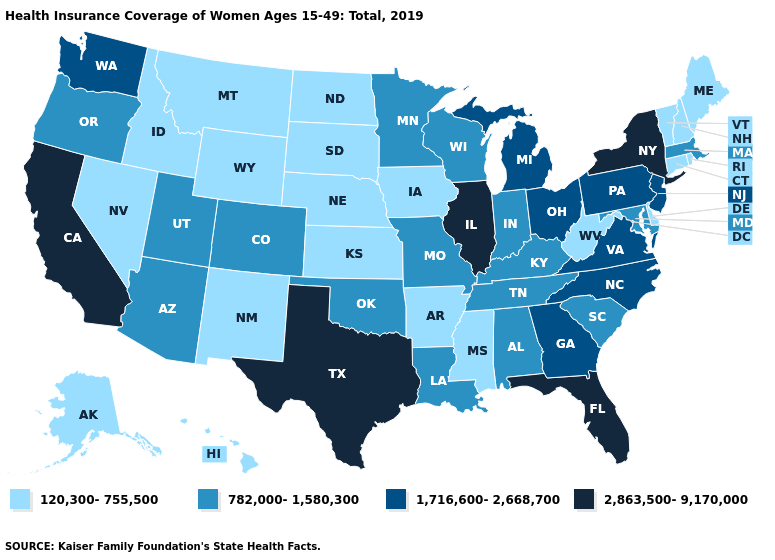Does Indiana have the same value as Pennsylvania?
Short answer required. No. What is the lowest value in the USA?
Be succinct. 120,300-755,500. How many symbols are there in the legend?
Write a very short answer. 4. What is the value of Utah?
Short answer required. 782,000-1,580,300. What is the value of Georgia?
Be succinct. 1,716,600-2,668,700. Name the states that have a value in the range 782,000-1,580,300?
Answer briefly. Alabama, Arizona, Colorado, Indiana, Kentucky, Louisiana, Maryland, Massachusetts, Minnesota, Missouri, Oklahoma, Oregon, South Carolina, Tennessee, Utah, Wisconsin. What is the value of Louisiana?
Quick response, please. 782,000-1,580,300. Does Rhode Island have a higher value than Alabama?
Write a very short answer. No. Does the map have missing data?
Quick response, please. No. Name the states that have a value in the range 1,716,600-2,668,700?
Quick response, please. Georgia, Michigan, New Jersey, North Carolina, Ohio, Pennsylvania, Virginia, Washington. What is the lowest value in the MidWest?
Keep it brief. 120,300-755,500. What is the value of Iowa?
Write a very short answer. 120,300-755,500. Does Nevada have a higher value than Illinois?
Quick response, please. No. Does California have the highest value in the West?
Give a very brief answer. Yes. 